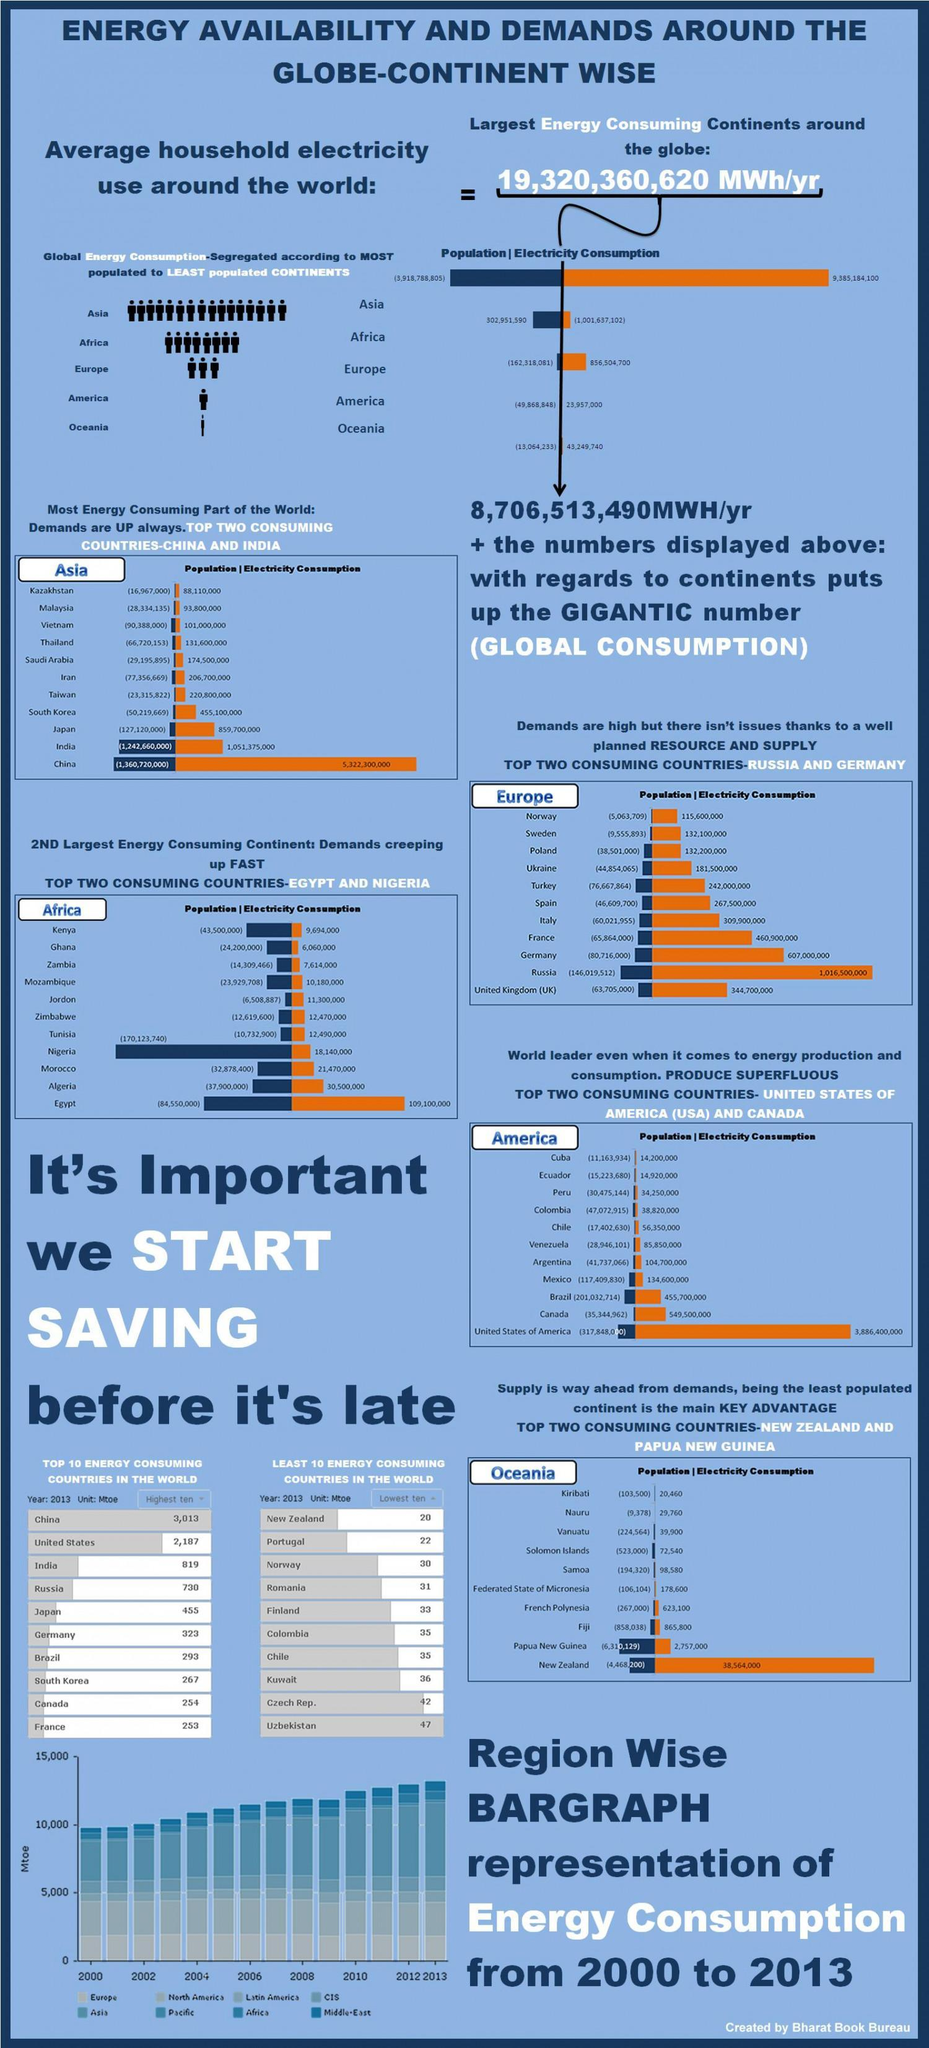Which continent is the largest consumer and records increasing in energy consumption from 2010 onwards?
Answer the question with a short phrase. Asia Which country is the highest consumer of electricity, Russia, China, or US? US What is the population of Canada ? 35,344,962 What is the electricity consumption in France? 460,900,000 Which country has the second least consumption of energy in the top 10 energy consuming countries? Canada Which country ranks consumes less energy than Colombia but more than Romania? Finland Which country has the third highest consumption of energy in the least 10 energy consuming countries? Kuwait Which continent has electricity consumption less than its population? Africa 